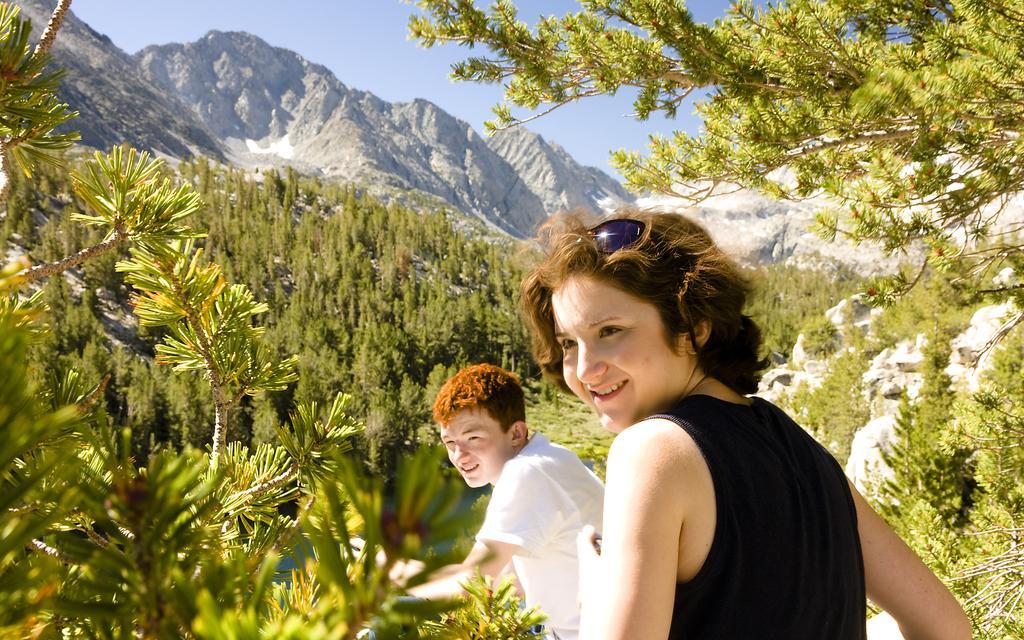Please provide a concise description of this image. In this image I can see two people are wearing black and white color dresses. Back I can see few green trees, mountains and sky is in blue color. 